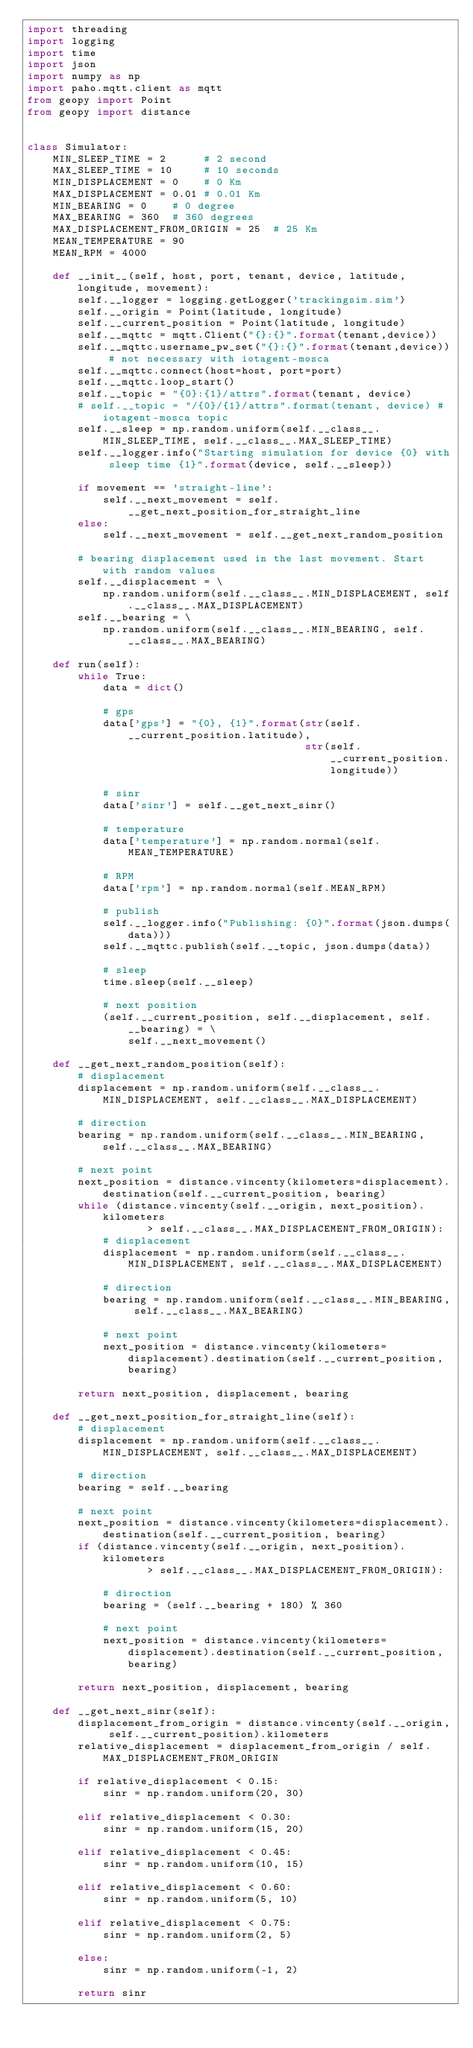<code> <loc_0><loc_0><loc_500><loc_500><_Python_>import threading
import logging
import time
import json
import numpy as np
import paho.mqtt.client as mqtt
from geopy import Point
from geopy import distance


class Simulator:
    MIN_SLEEP_TIME = 2      # 2 second
    MAX_SLEEP_TIME = 10     # 10 seconds
    MIN_DISPLACEMENT = 0    # 0 Km
    MAX_DISPLACEMENT = 0.01 # 0.01 Km
    MIN_BEARING = 0    # 0 degree
    MAX_BEARING = 360  # 360 degrees
    MAX_DISPLACEMENT_FROM_ORIGIN = 25  # 25 Km
    MEAN_TEMPERATURE = 90
    MEAN_RPM = 4000

    def __init__(self, host, port, tenant, device, latitude, longitude, movement):
        self.__logger = logging.getLogger('trackingsim.sim')
        self.__origin = Point(latitude, longitude)
        self.__current_position = Point(latitude, longitude)
        self.__mqttc = mqtt.Client("{}:{}".format(tenant,device))
        self.__mqttc.username_pw_set("{}:{}".format(tenant,device)) # not necessary with iotagent-mosca
        self.__mqttc.connect(host=host, port=port)
        self.__mqttc.loop_start()
        self.__topic = "{0}:{1}/attrs".format(tenant, device)
        # self.__topic = "/{0}/{1}/attrs".format(tenant, device) # iotagent-mosca topic
        self.__sleep = np.random.uniform(self.__class__.MIN_SLEEP_TIME, self.__class__.MAX_SLEEP_TIME)
        self.__logger.info("Starting simulation for device {0} with sleep time {1}".format(device, self.__sleep))

        if movement == 'straight-line':
            self.__next_movement = self.__get_next_position_for_straight_line
        else:
            self.__next_movement = self.__get_next_random_position

        # bearing displacement used in the last movement. Start with random values
        self.__displacement = \
            np.random.uniform(self.__class__.MIN_DISPLACEMENT, self.__class__.MAX_DISPLACEMENT)
        self.__bearing = \
            np.random.uniform(self.__class__.MIN_BEARING, self.__class__.MAX_BEARING)

    def run(self):
        while True:
            data = dict()

            # gps
            data['gps'] = "{0}, {1}".format(str(self.__current_position.latitude),
                                            str(self.__current_position.longitude))

            # sinr
            data['sinr'] = self.__get_next_sinr()

            # temperature
            data['temperature'] = np.random.normal(self.MEAN_TEMPERATURE)

            # RPM
            data['rpm'] = np.random.normal(self.MEAN_RPM)

            # publish
            self.__logger.info("Publishing: {0}".format(json.dumps(data)))
            self.__mqttc.publish(self.__topic, json.dumps(data))

            # sleep
            time.sleep(self.__sleep)

            # next position
            (self.__current_position, self.__displacement, self.__bearing) = \
                self.__next_movement()

    def __get_next_random_position(self):
        # displacement
        displacement = np.random.uniform(self.__class__.MIN_DISPLACEMENT, self.__class__.MAX_DISPLACEMENT)

        # direction
        bearing = np.random.uniform(self.__class__.MIN_BEARING, self.__class__.MAX_BEARING)

        # next point
        next_position = distance.vincenty(kilometers=displacement).destination(self.__current_position, bearing)
        while (distance.vincenty(self.__origin, next_position).kilometers
                   > self.__class__.MAX_DISPLACEMENT_FROM_ORIGIN):
            # displacement
            displacement = np.random.uniform(self.__class__.MIN_DISPLACEMENT, self.__class__.MAX_DISPLACEMENT)

            # direction
            bearing = np.random.uniform(self.__class__.MIN_BEARING, self.__class__.MAX_BEARING)

            # next point
            next_position = distance.vincenty(kilometers=displacement).destination(self.__current_position, bearing)

        return next_position, displacement, bearing

    def __get_next_position_for_straight_line(self):
        # displacement
        displacement = np.random.uniform(self.__class__.MIN_DISPLACEMENT, self.__class__.MAX_DISPLACEMENT)

        # direction
        bearing = self.__bearing

        # next point
        next_position = distance.vincenty(kilometers=displacement).destination(self.__current_position, bearing)
        if (distance.vincenty(self.__origin, next_position).kilometers
                   > self.__class__.MAX_DISPLACEMENT_FROM_ORIGIN):

            # direction
            bearing = (self.__bearing + 180) % 360

            # next point
            next_position = distance.vincenty(kilometers=displacement).destination(self.__current_position, bearing)

        return next_position, displacement, bearing

    def __get_next_sinr(self):
        displacement_from_origin = distance.vincenty(self.__origin, self.__current_position).kilometers
        relative_displacement = displacement_from_origin / self.MAX_DISPLACEMENT_FROM_ORIGIN

        if relative_displacement < 0.15:
            sinr = np.random.uniform(20, 30)

        elif relative_displacement < 0.30:
            sinr = np.random.uniform(15, 20)

        elif relative_displacement < 0.45:
            sinr = np.random.uniform(10, 15)

        elif relative_displacement < 0.60:
            sinr = np.random.uniform(5, 10)

        elif relative_displacement < 0.75:
            sinr = np.random.uniform(2, 5)

        else:
            sinr = np.random.uniform(-1, 2)

        return sinr
</code> 